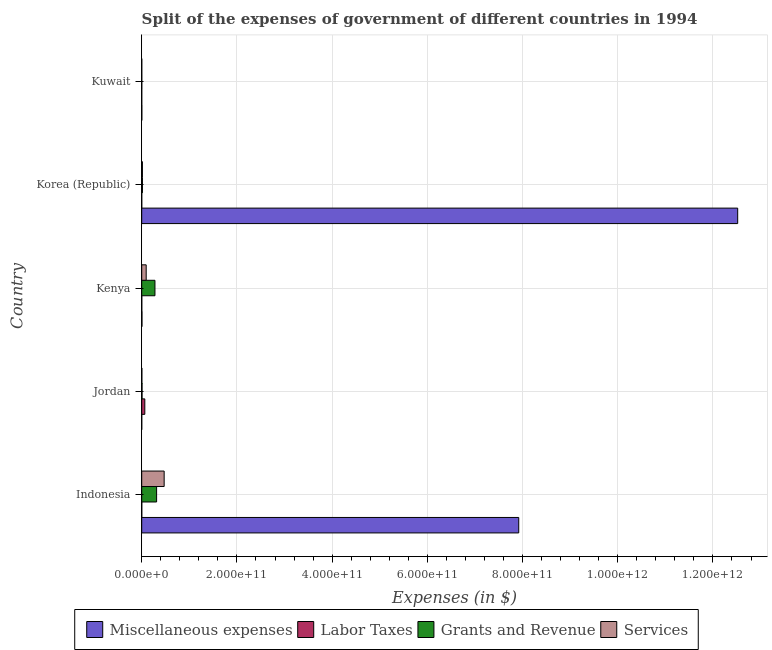How many different coloured bars are there?
Make the answer very short. 4. Are the number of bars per tick equal to the number of legend labels?
Provide a succinct answer. Yes. How many bars are there on the 4th tick from the bottom?
Keep it short and to the point. 4. What is the label of the 4th group of bars from the top?
Keep it short and to the point. Jordan. In how many cases, is the number of bars for a given country not equal to the number of legend labels?
Your response must be concise. 0. What is the amount spent on services in Korea (Republic)?
Offer a very short reply. 1.48e+09. Across all countries, what is the maximum amount spent on grants and revenue?
Provide a short and direct response. 3.13e+1. Across all countries, what is the minimum amount spent on services?
Provide a succinct answer. 8.89e+07. In which country was the amount spent on labor taxes maximum?
Give a very brief answer. Jordan. In which country was the amount spent on miscellaneous expenses minimum?
Ensure brevity in your answer.  Jordan. What is the total amount spent on labor taxes in the graph?
Provide a short and direct response. 6.73e+09. What is the difference between the amount spent on labor taxes in Jordan and that in Korea (Republic)?
Make the answer very short. 6.47e+09. What is the difference between the amount spent on miscellaneous expenses in Indonesia and the amount spent on grants and revenue in Jordan?
Give a very brief answer. 7.91e+11. What is the average amount spent on services per country?
Your answer should be very brief. 1.17e+1. What is the difference between the amount spent on grants and revenue and amount spent on labor taxes in Korea (Republic)?
Make the answer very short. 1.47e+09. In how many countries, is the amount spent on services greater than 680000000000 $?
Keep it short and to the point. 0. What is the ratio of the amount spent on services in Indonesia to that in Kuwait?
Offer a very short reply. 530.47. Is the amount spent on labor taxes in Jordan less than that in Kenya?
Keep it short and to the point. No. Is the difference between the amount spent on grants and revenue in Kenya and Kuwait greater than the difference between the amount spent on services in Kenya and Kuwait?
Your answer should be compact. Yes. What is the difference between the highest and the second highest amount spent on labor taxes?
Make the answer very short. 6.35e+09. What is the difference between the highest and the lowest amount spent on grants and revenue?
Your response must be concise. 3.11e+1. What does the 1st bar from the top in Kuwait represents?
Offer a terse response. Services. What does the 3rd bar from the bottom in Jordan represents?
Provide a short and direct response. Grants and Revenue. Is it the case that in every country, the sum of the amount spent on miscellaneous expenses and amount spent on labor taxes is greater than the amount spent on grants and revenue?
Make the answer very short. No. How many bars are there?
Provide a short and direct response. 20. How many countries are there in the graph?
Offer a very short reply. 5. What is the difference between two consecutive major ticks on the X-axis?
Offer a terse response. 2.00e+11. Where does the legend appear in the graph?
Your answer should be very brief. Bottom center. What is the title of the graph?
Offer a very short reply. Split of the expenses of government of different countries in 1994. What is the label or title of the X-axis?
Your answer should be very brief. Expenses (in $). What is the Expenses (in $) in Miscellaneous expenses in Indonesia?
Offer a terse response. 7.92e+11. What is the Expenses (in $) in Labor Taxes in Indonesia?
Your answer should be compact. 7.80e+07. What is the Expenses (in $) of Grants and Revenue in Indonesia?
Your answer should be compact. 3.13e+1. What is the Expenses (in $) of Services in Indonesia?
Provide a succinct answer. 4.71e+1. What is the Expenses (in $) of Miscellaneous expenses in Jordan?
Your answer should be compact. 3.34e+07. What is the Expenses (in $) in Labor Taxes in Jordan?
Keep it short and to the point. 6.49e+09. What is the Expenses (in $) in Grants and Revenue in Jordan?
Offer a terse response. 6.73e+08. What is the Expenses (in $) of Services in Jordan?
Provide a short and direct response. 3.00e+08. What is the Expenses (in $) in Miscellaneous expenses in Kenya?
Offer a terse response. 5.16e+08. What is the Expenses (in $) in Labor Taxes in Kenya?
Offer a terse response. 1.37e+08. What is the Expenses (in $) in Grants and Revenue in Kenya?
Your response must be concise. 2.78e+1. What is the Expenses (in $) of Services in Kenya?
Offer a terse response. 9.37e+09. What is the Expenses (in $) of Miscellaneous expenses in Korea (Republic)?
Keep it short and to the point. 1.25e+12. What is the Expenses (in $) in Labor Taxes in Korea (Republic)?
Provide a short and direct response. 2.05e+07. What is the Expenses (in $) in Grants and Revenue in Korea (Republic)?
Your answer should be very brief. 1.49e+09. What is the Expenses (in $) in Services in Korea (Republic)?
Provide a short and direct response. 1.48e+09. What is the Expenses (in $) of Miscellaneous expenses in Kuwait?
Make the answer very short. 2.33e+08. What is the Expenses (in $) in Labor Taxes in Kuwait?
Keep it short and to the point. 9.53e+06. What is the Expenses (in $) in Grants and Revenue in Kuwait?
Provide a succinct answer. 1.19e+08. What is the Expenses (in $) in Services in Kuwait?
Your answer should be compact. 8.89e+07. Across all countries, what is the maximum Expenses (in $) of Miscellaneous expenses?
Give a very brief answer. 1.25e+12. Across all countries, what is the maximum Expenses (in $) of Labor Taxes?
Offer a terse response. 6.49e+09. Across all countries, what is the maximum Expenses (in $) in Grants and Revenue?
Make the answer very short. 3.13e+1. Across all countries, what is the maximum Expenses (in $) in Services?
Provide a succinct answer. 4.71e+1. Across all countries, what is the minimum Expenses (in $) in Miscellaneous expenses?
Give a very brief answer. 3.34e+07. Across all countries, what is the minimum Expenses (in $) of Labor Taxes?
Provide a succinct answer. 9.53e+06. Across all countries, what is the minimum Expenses (in $) in Grants and Revenue?
Your answer should be very brief. 1.19e+08. Across all countries, what is the minimum Expenses (in $) in Services?
Offer a terse response. 8.89e+07. What is the total Expenses (in $) of Miscellaneous expenses in the graph?
Offer a terse response. 2.04e+12. What is the total Expenses (in $) in Labor Taxes in the graph?
Offer a very short reply. 6.73e+09. What is the total Expenses (in $) of Grants and Revenue in the graph?
Provide a succinct answer. 6.13e+1. What is the total Expenses (in $) in Services in the graph?
Keep it short and to the point. 5.84e+1. What is the difference between the Expenses (in $) in Miscellaneous expenses in Indonesia and that in Jordan?
Offer a very short reply. 7.92e+11. What is the difference between the Expenses (in $) in Labor Taxes in Indonesia and that in Jordan?
Offer a very short reply. -6.41e+09. What is the difference between the Expenses (in $) of Grants and Revenue in Indonesia and that in Jordan?
Provide a short and direct response. 3.06e+1. What is the difference between the Expenses (in $) of Services in Indonesia and that in Jordan?
Give a very brief answer. 4.68e+1. What is the difference between the Expenses (in $) of Miscellaneous expenses in Indonesia and that in Kenya?
Make the answer very short. 7.91e+11. What is the difference between the Expenses (in $) of Labor Taxes in Indonesia and that in Kenya?
Your answer should be compact. -5.90e+07. What is the difference between the Expenses (in $) in Grants and Revenue in Indonesia and that in Kenya?
Your answer should be compact. 3.46e+09. What is the difference between the Expenses (in $) of Services in Indonesia and that in Kenya?
Provide a short and direct response. 3.78e+1. What is the difference between the Expenses (in $) in Miscellaneous expenses in Indonesia and that in Korea (Republic)?
Offer a very short reply. -4.60e+11. What is the difference between the Expenses (in $) of Labor Taxes in Indonesia and that in Korea (Republic)?
Your answer should be very brief. 5.75e+07. What is the difference between the Expenses (in $) in Grants and Revenue in Indonesia and that in Korea (Republic)?
Make the answer very short. 2.98e+1. What is the difference between the Expenses (in $) of Services in Indonesia and that in Korea (Republic)?
Make the answer very short. 4.57e+1. What is the difference between the Expenses (in $) of Miscellaneous expenses in Indonesia and that in Kuwait?
Provide a short and direct response. 7.92e+11. What is the difference between the Expenses (in $) in Labor Taxes in Indonesia and that in Kuwait?
Give a very brief answer. 6.85e+07. What is the difference between the Expenses (in $) in Grants and Revenue in Indonesia and that in Kuwait?
Offer a very short reply. 3.11e+1. What is the difference between the Expenses (in $) in Services in Indonesia and that in Kuwait?
Your answer should be very brief. 4.71e+1. What is the difference between the Expenses (in $) of Miscellaneous expenses in Jordan and that in Kenya?
Provide a short and direct response. -4.83e+08. What is the difference between the Expenses (in $) of Labor Taxes in Jordan and that in Kenya?
Your answer should be very brief. 6.35e+09. What is the difference between the Expenses (in $) in Grants and Revenue in Jordan and that in Kenya?
Offer a very short reply. -2.71e+1. What is the difference between the Expenses (in $) in Services in Jordan and that in Kenya?
Your answer should be very brief. -9.07e+09. What is the difference between the Expenses (in $) in Miscellaneous expenses in Jordan and that in Korea (Republic)?
Keep it short and to the point. -1.25e+12. What is the difference between the Expenses (in $) in Labor Taxes in Jordan and that in Korea (Republic)?
Your answer should be very brief. 6.47e+09. What is the difference between the Expenses (in $) in Grants and Revenue in Jordan and that in Korea (Republic)?
Your answer should be compact. -8.20e+08. What is the difference between the Expenses (in $) in Services in Jordan and that in Korea (Republic)?
Give a very brief answer. -1.18e+09. What is the difference between the Expenses (in $) of Miscellaneous expenses in Jordan and that in Kuwait?
Keep it short and to the point. -2.00e+08. What is the difference between the Expenses (in $) in Labor Taxes in Jordan and that in Kuwait?
Make the answer very short. 6.48e+09. What is the difference between the Expenses (in $) in Grants and Revenue in Jordan and that in Kuwait?
Your answer should be compact. 5.54e+08. What is the difference between the Expenses (in $) in Services in Jordan and that in Kuwait?
Offer a terse response. 2.11e+08. What is the difference between the Expenses (in $) in Miscellaneous expenses in Kenya and that in Korea (Republic)?
Provide a short and direct response. -1.25e+12. What is the difference between the Expenses (in $) in Labor Taxes in Kenya and that in Korea (Republic)?
Ensure brevity in your answer.  1.17e+08. What is the difference between the Expenses (in $) of Grants and Revenue in Kenya and that in Korea (Republic)?
Keep it short and to the point. 2.63e+1. What is the difference between the Expenses (in $) of Services in Kenya and that in Korea (Republic)?
Your answer should be very brief. 7.89e+09. What is the difference between the Expenses (in $) of Miscellaneous expenses in Kenya and that in Kuwait?
Your answer should be compact. 2.83e+08. What is the difference between the Expenses (in $) in Labor Taxes in Kenya and that in Kuwait?
Ensure brevity in your answer.  1.27e+08. What is the difference between the Expenses (in $) in Grants and Revenue in Kenya and that in Kuwait?
Keep it short and to the point. 2.77e+1. What is the difference between the Expenses (in $) of Services in Kenya and that in Kuwait?
Make the answer very short. 9.28e+09. What is the difference between the Expenses (in $) of Miscellaneous expenses in Korea (Republic) and that in Kuwait?
Make the answer very short. 1.25e+12. What is the difference between the Expenses (in $) in Labor Taxes in Korea (Republic) and that in Kuwait?
Ensure brevity in your answer.  1.09e+07. What is the difference between the Expenses (in $) of Grants and Revenue in Korea (Republic) and that in Kuwait?
Give a very brief answer. 1.37e+09. What is the difference between the Expenses (in $) in Services in Korea (Republic) and that in Kuwait?
Make the answer very short. 1.39e+09. What is the difference between the Expenses (in $) of Miscellaneous expenses in Indonesia and the Expenses (in $) of Labor Taxes in Jordan?
Keep it short and to the point. 7.86e+11. What is the difference between the Expenses (in $) of Miscellaneous expenses in Indonesia and the Expenses (in $) of Grants and Revenue in Jordan?
Make the answer very short. 7.91e+11. What is the difference between the Expenses (in $) in Miscellaneous expenses in Indonesia and the Expenses (in $) in Services in Jordan?
Your answer should be very brief. 7.92e+11. What is the difference between the Expenses (in $) in Labor Taxes in Indonesia and the Expenses (in $) in Grants and Revenue in Jordan?
Give a very brief answer. -5.95e+08. What is the difference between the Expenses (in $) of Labor Taxes in Indonesia and the Expenses (in $) of Services in Jordan?
Make the answer very short. -2.22e+08. What is the difference between the Expenses (in $) in Grants and Revenue in Indonesia and the Expenses (in $) in Services in Jordan?
Your response must be concise. 3.10e+1. What is the difference between the Expenses (in $) of Miscellaneous expenses in Indonesia and the Expenses (in $) of Labor Taxes in Kenya?
Give a very brief answer. 7.92e+11. What is the difference between the Expenses (in $) in Miscellaneous expenses in Indonesia and the Expenses (in $) in Grants and Revenue in Kenya?
Offer a very short reply. 7.64e+11. What is the difference between the Expenses (in $) in Miscellaneous expenses in Indonesia and the Expenses (in $) in Services in Kenya?
Your response must be concise. 7.83e+11. What is the difference between the Expenses (in $) in Labor Taxes in Indonesia and the Expenses (in $) in Grants and Revenue in Kenya?
Offer a very short reply. -2.77e+1. What is the difference between the Expenses (in $) of Labor Taxes in Indonesia and the Expenses (in $) of Services in Kenya?
Make the answer very short. -9.29e+09. What is the difference between the Expenses (in $) in Grants and Revenue in Indonesia and the Expenses (in $) in Services in Kenya?
Ensure brevity in your answer.  2.19e+1. What is the difference between the Expenses (in $) in Miscellaneous expenses in Indonesia and the Expenses (in $) in Labor Taxes in Korea (Republic)?
Offer a very short reply. 7.92e+11. What is the difference between the Expenses (in $) of Miscellaneous expenses in Indonesia and the Expenses (in $) of Grants and Revenue in Korea (Republic)?
Make the answer very short. 7.91e+11. What is the difference between the Expenses (in $) in Miscellaneous expenses in Indonesia and the Expenses (in $) in Services in Korea (Republic)?
Ensure brevity in your answer.  7.91e+11. What is the difference between the Expenses (in $) in Labor Taxes in Indonesia and the Expenses (in $) in Grants and Revenue in Korea (Republic)?
Offer a very short reply. -1.41e+09. What is the difference between the Expenses (in $) of Labor Taxes in Indonesia and the Expenses (in $) of Services in Korea (Republic)?
Your answer should be compact. -1.40e+09. What is the difference between the Expenses (in $) in Grants and Revenue in Indonesia and the Expenses (in $) in Services in Korea (Republic)?
Give a very brief answer. 2.98e+1. What is the difference between the Expenses (in $) of Miscellaneous expenses in Indonesia and the Expenses (in $) of Labor Taxes in Kuwait?
Offer a terse response. 7.92e+11. What is the difference between the Expenses (in $) in Miscellaneous expenses in Indonesia and the Expenses (in $) in Grants and Revenue in Kuwait?
Your answer should be compact. 7.92e+11. What is the difference between the Expenses (in $) of Miscellaneous expenses in Indonesia and the Expenses (in $) of Services in Kuwait?
Give a very brief answer. 7.92e+11. What is the difference between the Expenses (in $) in Labor Taxes in Indonesia and the Expenses (in $) in Grants and Revenue in Kuwait?
Make the answer very short. -4.07e+07. What is the difference between the Expenses (in $) of Labor Taxes in Indonesia and the Expenses (in $) of Services in Kuwait?
Offer a terse response. -1.09e+07. What is the difference between the Expenses (in $) of Grants and Revenue in Indonesia and the Expenses (in $) of Services in Kuwait?
Your answer should be very brief. 3.12e+1. What is the difference between the Expenses (in $) of Miscellaneous expenses in Jordan and the Expenses (in $) of Labor Taxes in Kenya?
Offer a terse response. -1.04e+08. What is the difference between the Expenses (in $) in Miscellaneous expenses in Jordan and the Expenses (in $) in Grants and Revenue in Kenya?
Offer a terse response. -2.78e+1. What is the difference between the Expenses (in $) of Miscellaneous expenses in Jordan and the Expenses (in $) of Services in Kenya?
Provide a succinct answer. -9.34e+09. What is the difference between the Expenses (in $) of Labor Taxes in Jordan and the Expenses (in $) of Grants and Revenue in Kenya?
Your answer should be very brief. -2.13e+1. What is the difference between the Expenses (in $) of Labor Taxes in Jordan and the Expenses (in $) of Services in Kenya?
Offer a terse response. -2.88e+09. What is the difference between the Expenses (in $) of Grants and Revenue in Jordan and the Expenses (in $) of Services in Kenya?
Offer a terse response. -8.70e+09. What is the difference between the Expenses (in $) of Miscellaneous expenses in Jordan and the Expenses (in $) of Labor Taxes in Korea (Republic)?
Keep it short and to the point. 1.29e+07. What is the difference between the Expenses (in $) in Miscellaneous expenses in Jordan and the Expenses (in $) in Grants and Revenue in Korea (Republic)?
Offer a terse response. -1.46e+09. What is the difference between the Expenses (in $) in Miscellaneous expenses in Jordan and the Expenses (in $) in Services in Korea (Republic)?
Offer a very short reply. -1.44e+09. What is the difference between the Expenses (in $) in Labor Taxes in Jordan and the Expenses (in $) in Grants and Revenue in Korea (Republic)?
Provide a short and direct response. 5.00e+09. What is the difference between the Expenses (in $) in Labor Taxes in Jordan and the Expenses (in $) in Services in Korea (Republic)?
Offer a terse response. 5.01e+09. What is the difference between the Expenses (in $) of Grants and Revenue in Jordan and the Expenses (in $) of Services in Korea (Republic)?
Offer a terse response. -8.05e+08. What is the difference between the Expenses (in $) in Miscellaneous expenses in Jordan and the Expenses (in $) in Labor Taxes in Kuwait?
Make the answer very short. 2.38e+07. What is the difference between the Expenses (in $) of Miscellaneous expenses in Jordan and the Expenses (in $) of Grants and Revenue in Kuwait?
Your response must be concise. -8.53e+07. What is the difference between the Expenses (in $) in Miscellaneous expenses in Jordan and the Expenses (in $) in Services in Kuwait?
Provide a short and direct response. -5.55e+07. What is the difference between the Expenses (in $) of Labor Taxes in Jordan and the Expenses (in $) of Grants and Revenue in Kuwait?
Provide a short and direct response. 6.37e+09. What is the difference between the Expenses (in $) in Labor Taxes in Jordan and the Expenses (in $) in Services in Kuwait?
Ensure brevity in your answer.  6.40e+09. What is the difference between the Expenses (in $) in Grants and Revenue in Jordan and the Expenses (in $) in Services in Kuwait?
Ensure brevity in your answer.  5.84e+08. What is the difference between the Expenses (in $) of Miscellaneous expenses in Kenya and the Expenses (in $) of Labor Taxes in Korea (Republic)?
Make the answer very short. 4.96e+08. What is the difference between the Expenses (in $) in Miscellaneous expenses in Kenya and the Expenses (in $) in Grants and Revenue in Korea (Republic)?
Provide a short and direct response. -9.77e+08. What is the difference between the Expenses (in $) in Miscellaneous expenses in Kenya and the Expenses (in $) in Services in Korea (Republic)?
Offer a terse response. -9.62e+08. What is the difference between the Expenses (in $) in Labor Taxes in Kenya and the Expenses (in $) in Grants and Revenue in Korea (Republic)?
Ensure brevity in your answer.  -1.36e+09. What is the difference between the Expenses (in $) in Labor Taxes in Kenya and the Expenses (in $) in Services in Korea (Republic)?
Offer a terse response. -1.34e+09. What is the difference between the Expenses (in $) in Grants and Revenue in Kenya and the Expenses (in $) in Services in Korea (Republic)?
Give a very brief answer. 2.63e+1. What is the difference between the Expenses (in $) in Miscellaneous expenses in Kenya and the Expenses (in $) in Labor Taxes in Kuwait?
Provide a succinct answer. 5.06e+08. What is the difference between the Expenses (in $) in Miscellaneous expenses in Kenya and the Expenses (in $) in Grants and Revenue in Kuwait?
Your response must be concise. 3.97e+08. What is the difference between the Expenses (in $) of Miscellaneous expenses in Kenya and the Expenses (in $) of Services in Kuwait?
Provide a succinct answer. 4.27e+08. What is the difference between the Expenses (in $) of Labor Taxes in Kenya and the Expenses (in $) of Grants and Revenue in Kuwait?
Ensure brevity in your answer.  1.83e+07. What is the difference between the Expenses (in $) in Labor Taxes in Kenya and the Expenses (in $) in Services in Kuwait?
Your answer should be very brief. 4.81e+07. What is the difference between the Expenses (in $) of Grants and Revenue in Kenya and the Expenses (in $) of Services in Kuwait?
Your response must be concise. 2.77e+1. What is the difference between the Expenses (in $) in Miscellaneous expenses in Korea (Republic) and the Expenses (in $) in Labor Taxes in Kuwait?
Provide a succinct answer. 1.25e+12. What is the difference between the Expenses (in $) of Miscellaneous expenses in Korea (Republic) and the Expenses (in $) of Grants and Revenue in Kuwait?
Offer a terse response. 1.25e+12. What is the difference between the Expenses (in $) of Miscellaneous expenses in Korea (Republic) and the Expenses (in $) of Services in Kuwait?
Ensure brevity in your answer.  1.25e+12. What is the difference between the Expenses (in $) of Labor Taxes in Korea (Republic) and the Expenses (in $) of Grants and Revenue in Kuwait?
Your answer should be compact. -9.82e+07. What is the difference between the Expenses (in $) of Labor Taxes in Korea (Republic) and the Expenses (in $) of Services in Kuwait?
Your answer should be very brief. -6.84e+07. What is the difference between the Expenses (in $) in Grants and Revenue in Korea (Republic) and the Expenses (in $) in Services in Kuwait?
Offer a terse response. 1.40e+09. What is the average Expenses (in $) of Miscellaneous expenses per country?
Offer a very short reply. 4.09e+11. What is the average Expenses (in $) of Labor Taxes per country?
Your answer should be very brief. 1.35e+09. What is the average Expenses (in $) of Grants and Revenue per country?
Give a very brief answer. 1.23e+1. What is the average Expenses (in $) in Services per country?
Provide a succinct answer. 1.17e+1. What is the difference between the Expenses (in $) of Miscellaneous expenses and Expenses (in $) of Labor Taxes in Indonesia?
Your answer should be very brief. 7.92e+11. What is the difference between the Expenses (in $) of Miscellaneous expenses and Expenses (in $) of Grants and Revenue in Indonesia?
Offer a very short reply. 7.61e+11. What is the difference between the Expenses (in $) in Miscellaneous expenses and Expenses (in $) in Services in Indonesia?
Make the answer very short. 7.45e+11. What is the difference between the Expenses (in $) in Labor Taxes and Expenses (in $) in Grants and Revenue in Indonesia?
Your answer should be compact. -3.12e+1. What is the difference between the Expenses (in $) of Labor Taxes and Expenses (in $) of Services in Indonesia?
Keep it short and to the point. -4.71e+1. What is the difference between the Expenses (in $) of Grants and Revenue and Expenses (in $) of Services in Indonesia?
Provide a short and direct response. -1.59e+1. What is the difference between the Expenses (in $) of Miscellaneous expenses and Expenses (in $) of Labor Taxes in Jordan?
Ensure brevity in your answer.  -6.46e+09. What is the difference between the Expenses (in $) in Miscellaneous expenses and Expenses (in $) in Grants and Revenue in Jordan?
Your answer should be compact. -6.40e+08. What is the difference between the Expenses (in $) in Miscellaneous expenses and Expenses (in $) in Services in Jordan?
Provide a short and direct response. -2.67e+08. What is the difference between the Expenses (in $) in Labor Taxes and Expenses (in $) in Grants and Revenue in Jordan?
Make the answer very short. 5.82e+09. What is the difference between the Expenses (in $) in Labor Taxes and Expenses (in $) in Services in Jordan?
Give a very brief answer. 6.19e+09. What is the difference between the Expenses (in $) in Grants and Revenue and Expenses (in $) in Services in Jordan?
Your answer should be very brief. 3.73e+08. What is the difference between the Expenses (in $) of Miscellaneous expenses and Expenses (in $) of Labor Taxes in Kenya?
Offer a terse response. 3.79e+08. What is the difference between the Expenses (in $) of Miscellaneous expenses and Expenses (in $) of Grants and Revenue in Kenya?
Make the answer very short. -2.73e+1. What is the difference between the Expenses (in $) of Miscellaneous expenses and Expenses (in $) of Services in Kenya?
Provide a short and direct response. -8.86e+09. What is the difference between the Expenses (in $) of Labor Taxes and Expenses (in $) of Grants and Revenue in Kenya?
Keep it short and to the point. -2.77e+1. What is the difference between the Expenses (in $) in Labor Taxes and Expenses (in $) in Services in Kenya?
Keep it short and to the point. -9.23e+09. What is the difference between the Expenses (in $) in Grants and Revenue and Expenses (in $) in Services in Kenya?
Provide a short and direct response. 1.84e+1. What is the difference between the Expenses (in $) of Miscellaneous expenses and Expenses (in $) of Labor Taxes in Korea (Republic)?
Your answer should be very brief. 1.25e+12. What is the difference between the Expenses (in $) of Miscellaneous expenses and Expenses (in $) of Grants and Revenue in Korea (Republic)?
Offer a very short reply. 1.25e+12. What is the difference between the Expenses (in $) of Miscellaneous expenses and Expenses (in $) of Services in Korea (Republic)?
Offer a terse response. 1.25e+12. What is the difference between the Expenses (in $) of Labor Taxes and Expenses (in $) of Grants and Revenue in Korea (Republic)?
Keep it short and to the point. -1.47e+09. What is the difference between the Expenses (in $) in Labor Taxes and Expenses (in $) in Services in Korea (Republic)?
Ensure brevity in your answer.  -1.46e+09. What is the difference between the Expenses (in $) in Grants and Revenue and Expenses (in $) in Services in Korea (Republic)?
Make the answer very short. 1.48e+07. What is the difference between the Expenses (in $) in Miscellaneous expenses and Expenses (in $) in Labor Taxes in Kuwait?
Offer a terse response. 2.23e+08. What is the difference between the Expenses (in $) of Miscellaneous expenses and Expenses (in $) of Grants and Revenue in Kuwait?
Keep it short and to the point. 1.14e+08. What is the difference between the Expenses (in $) of Miscellaneous expenses and Expenses (in $) of Services in Kuwait?
Provide a succinct answer. 1.44e+08. What is the difference between the Expenses (in $) in Labor Taxes and Expenses (in $) in Grants and Revenue in Kuwait?
Your answer should be compact. -1.09e+08. What is the difference between the Expenses (in $) in Labor Taxes and Expenses (in $) in Services in Kuwait?
Make the answer very short. -7.93e+07. What is the difference between the Expenses (in $) of Grants and Revenue and Expenses (in $) of Services in Kuwait?
Ensure brevity in your answer.  2.98e+07. What is the ratio of the Expenses (in $) in Miscellaneous expenses in Indonesia to that in Jordan?
Ensure brevity in your answer.  2.37e+04. What is the ratio of the Expenses (in $) in Labor Taxes in Indonesia to that in Jordan?
Offer a very short reply. 0.01. What is the ratio of the Expenses (in $) of Grants and Revenue in Indonesia to that in Jordan?
Provide a short and direct response. 46.45. What is the ratio of the Expenses (in $) in Services in Indonesia to that in Jordan?
Your answer should be compact. 157.14. What is the ratio of the Expenses (in $) in Miscellaneous expenses in Indonesia to that in Kenya?
Give a very brief answer. 1534.88. What is the ratio of the Expenses (in $) of Labor Taxes in Indonesia to that in Kenya?
Offer a terse response. 0.57. What is the ratio of the Expenses (in $) of Grants and Revenue in Indonesia to that in Kenya?
Offer a terse response. 1.12. What is the ratio of the Expenses (in $) in Services in Indonesia to that in Kenya?
Your answer should be compact. 5.03. What is the ratio of the Expenses (in $) of Miscellaneous expenses in Indonesia to that in Korea (Republic)?
Keep it short and to the point. 0.63. What is the ratio of the Expenses (in $) of Labor Taxes in Indonesia to that in Korea (Republic)?
Your answer should be compact. 3.81. What is the ratio of the Expenses (in $) in Grants and Revenue in Indonesia to that in Korea (Republic)?
Your response must be concise. 20.94. What is the ratio of the Expenses (in $) of Services in Indonesia to that in Korea (Republic)?
Provide a short and direct response. 31.9. What is the ratio of the Expenses (in $) of Miscellaneous expenses in Indonesia to that in Kuwait?
Keep it short and to the point. 3399.14. What is the ratio of the Expenses (in $) in Labor Taxes in Indonesia to that in Kuwait?
Your response must be concise. 8.18. What is the ratio of the Expenses (in $) of Grants and Revenue in Indonesia to that in Kuwait?
Give a very brief answer. 263.41. What is the ratio of the Expenses (in $) in Services in Indonesia to that in Kuwait?
Offer a very short reply. 530.47. What is the ratio of the Expenses (in $) in Miscellaneous expenses in Jordan to that in Kenya?
Give a very brief answer. 0.06. What is the ratio of the Expenses (in $) of Labor Taxes in Jordan to that in Kenya?
Your answer should be compact. 47.37. What is the ratio of the Expenses (in $) of Grants and Revenue in Jordan to that in Kenya?
Provide a short and direct response. 0.02. What is the ratio of the Expenses (in $) of Services in Jordan to that in Kenya?
Make the answer very short. 0.03. What is the ratio of the Expenses (in $) of Miscellaneous expenses in Jordan to that in Korea (Republic)?
Your answer should be very brief. 0. What is the ratio of the Expenses (in $) in Labor Taxes in Jordan to that in Korea (Republic)?
Provide a succinct answer. 317. What is the ratio of the Expenses (in $) of Grants and Revenue in Jordan to that in Korea (Republic)?
Keep it short and to the point. 0.45. What is the ratio of the Expenses (in $) in Services in Jordan to that in Korea (Republic)?
Your answer should be very brief. 0.2. What is the ratio of the Expenses (in $) in Miscellaneous expenses in Jordan to that in Kuwait?
Your answer should be compact. 0.14. What is the ratio of the Expenses (in $) of Labor Taxes in Jordan to that in Kuwait?
Make the answer very short. 680.9. What is the ratio of the Expenses (in $) in Grants and Revenue in Jordan to that in Kuwait?
Your answer should be compact. 5.67. What is the ratio of the Expenses (in $) in Services in Jordan to that in Kuwait?
Offer a terse response. 3.38. What is the ratio of the Expenses (in $) of Miscellaneous expenses in Kenya to that in Korea (Republic)?
Make the answer very short. 0. What is the ratio of the Expenses (in $) of Labor Taxes in Kenya to that in Korea (Republic)?
Offer a terse response. 6.69. What is the ratio of the Expenses (in $) of Grants and Revenue in Kenya to that in Korea (Republic)?
Offer a very short reply. 18.62. What is the ratio of the Expenses (in $) of Services in Kenya to that in Korea (Republic)?
Keep it short and to the point. 6.34. What is the ratio of the Expenses (in $) of Miscellaneous expenses in Kenya to that in Kuwait?
Keep it short and to the point. 2.21. What is the ratio of the Expenses (in $) of Labor Taxes in Kenya to that in Kuwait?
Provide a succinct answer. 14.38. What is the ratio of the Expenses (in $) of Grants and Revenue in Kenya to that in Kuwait?
Provide a short and direct response. 234.23. What is the ratio of the Expenses (in $) of Services in Kenya to that in Kuwait?
Offer a very short reply. 105.45. What is the ratio of the Expenses (in $) of Miscellaneous expenses in Korea (Republic) to that in Kuwait?
Ensure brevity in your answer.  5373.39. What is the ratio of the Expenses (in $) of Labor Taxes in Korea (Republic) to that in Kuwait?
Offer a very short reply. 2.15. What is the ratio of the Expenses (in $) of Grants and Revenue in Korea (Republic) to that in Kuwait?
Give a very brief answer. 12.58. What is the ratio of the Expenses (in $) in Services in Korea (Republic) to that in Kuwait?
Your response must be concise. 16.63. What is the difference between the highest and the second highest Expenses (in $) in Miscellaneous expenses?
Your answer should be compact. 4.60e+11. What is the difference between the highest and the second highest Expenses (in $) of Labor Taxes?
Ensure brevity in your answer.  6.35e+09. What is the difference between the highest and the second highest Expenses (in $) in Grants and Revenue?
Provide a short and direct response. 3.46e+09. What is the difference between the highest and the second highest Expenses (in $) of Services?
Provide a short and direct response. 3.78e+1. What is the difference between the highest and the lowest Expenses (in $) of Miscellaneous expenses?
Your response must be concise. 1.25e+12. What is the difference between the highest and the lowest Expenses (in $) in Labor Taxes?
Give a very brief answer. 6.48e+09. What is the difference between the highest and the lowest Expenses (in $) in Grants and Revenue?
Provide a succinct answer. 3.11e+1. What is the difference between the highest and the lowest Expenses (in $) in Services?
Your answer should be compact. 4.71e+1. 